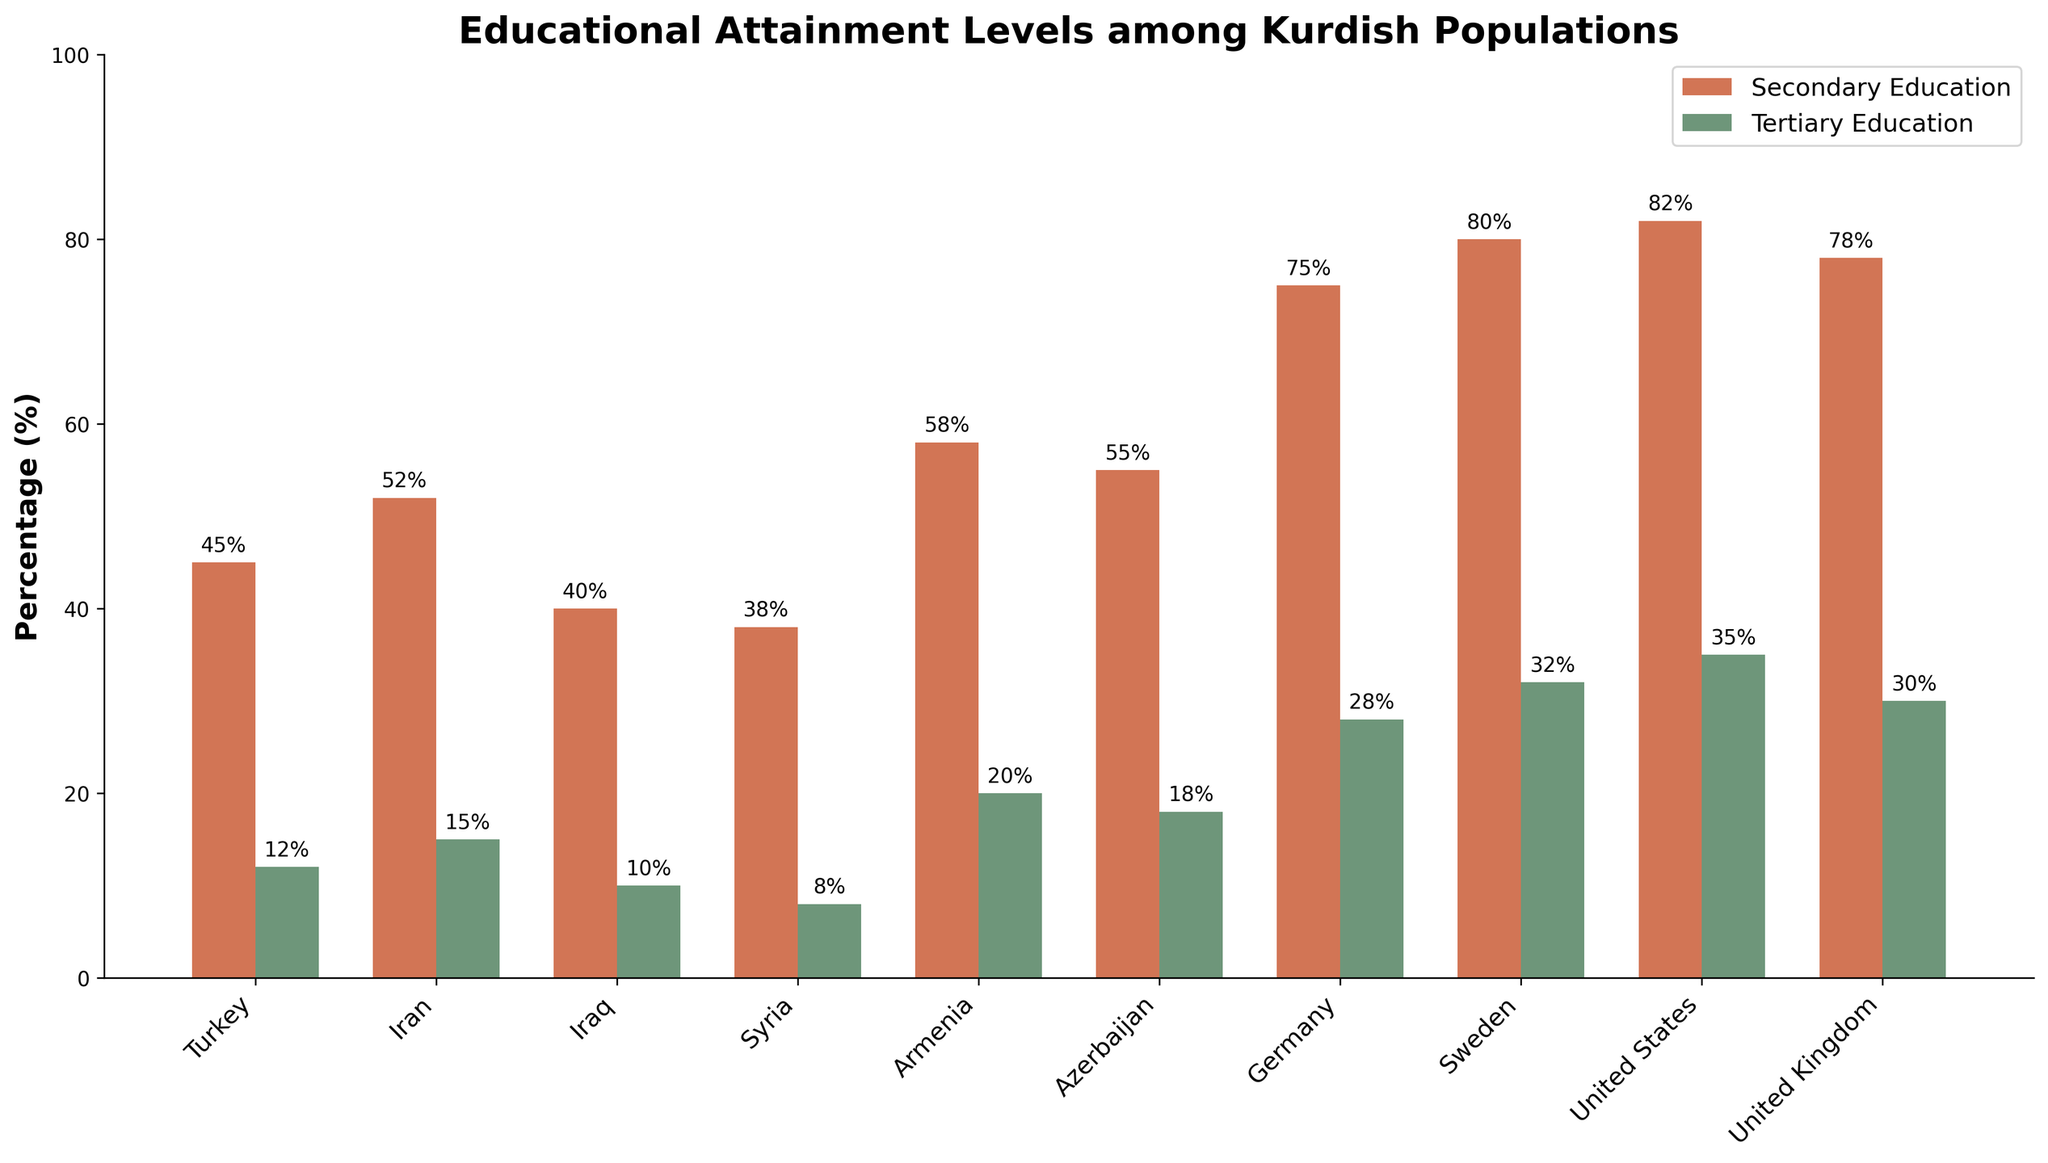Which country has the highest percentage of secondary education among Kurdish populations? The country with the highest percentage of secondary education can be identified by looking at the tallest bar for secondary education.
Answer: United States Which country has the lowest percentage of tertiary education among Kurdish populations? The country with the lowest percentage of tertiary education can be identified by looking at the shortest bar for tertiary education.
Answer: Syria What is the difference in the percentage of secondary education between Germany and Turkey? The percentage of secondary education in Germany is 75% and in Turkey is 45%. Subtract Turkey's percentage from Germany's percentage (75% - 45%)
Answer: 30% How does the percentage of tertiary education in Sweden compare to that in the United Kingdom? From the chart, Sweden has a tertiary education percentage of 32% while the United Kingdom has 30%. Sweden's percentage is higher than that of the United Kingdom.
Answer: Sweden's percentage is higher What is the average percentage of tertiary education across all listed countries? Sum the tertiary education percentages and divide by the number of countries. (12+15+10+8+20+18+28+32+35+30)/10 = 208/10
Answer: 20.8% Which countries have a higher percentage of secondary education than tertiary education? By comparing the heights of secondary education bars to tertiary education bars for each country, it can be seen that all countries have higher secondary education percentages than tertiary education percentages.
Answer: All countries Which country has the smallest difference between secondary and tertiary education percentages? Calculate the difference between secondary and tertiary education percentages for all countries and find the smallest difference.
Answer: United States (82%-35% = 47%) Across the Middle Eastern countries listed (Turkey, Iran, Iraq, Syria), which has the highest combined percentage of secondary and tertiary education? Add secondary and tertiary education percentages for Turkey, Iran, Iraq, and Syria, then compare. Iran has 52% + 15% = 67%. Turkey has 45% + 12% = 57%. Iraq has 40% + 10% = 50%. Syria has 38% + 8% = 46%.
Answer: Iran What is the percentage gap between secondary education in the country with the highest secondary education and the country with the lowest? Identify the highest and lowest secondary education percentages: United States (82%) and Syria (38%). Subtract the lowest from the highest (82% - 38%)
Answer: 44% Which country has the highest percentage of tertiary education? Look for the tallest bar representing tertiary education.
Answer: United States 